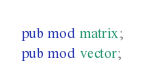<code> <loc_0><loc_0><loc_500><loc_500><_Rust_>pub mod matrix;
pub mod vector;</code> 